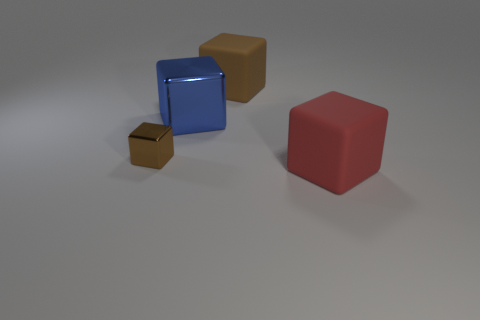Does the thing to the right of the brown rubber object have the same size as the brown rubber thing that is behind the small brown cube?
Provide a short and direct response. Yes. There is a brown object behind the brown cube in front of the big rubber thing that is to the left of the red rubber cube; what is its size?
Your answer should be very brief. Large. What is the shape of the brown thing that is in front of the big rubber block that is behind the big thing that is in front of the small brown cube?
Make the answer very short. Cube. What shape is the big matte thing behind the big red cube?
Provide a short and direct response. Cube. Do the large blue cube and the large object behind the blue block have the same material?
Your answer should be very brief. No. What number of other things are there of the same shape as the big blue object?
Keep it short and to the point. 3. There is a tiny cube; is it the same color as the large matte cube that is behind the big metallic cube?
Offer a terse response. Yes. Are there any other things that have the same material as the blue object?
Offer a very short reply. Yes. The big thing that is on the left side of the large block behind the large blue block is what shape?
Keep it short and to the point. Cube. What size is the cube that is the same color as the small shiny object?
Give a very brief answer. Large. 